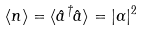<formula> <loc_0><loc_0><loc_500><loc_500>\langle n \rangle = \langle { \hat { a } } ^ { \dagger } { \hat { a } } \rangle = | \alpha | ^ { 2 }</formula> 